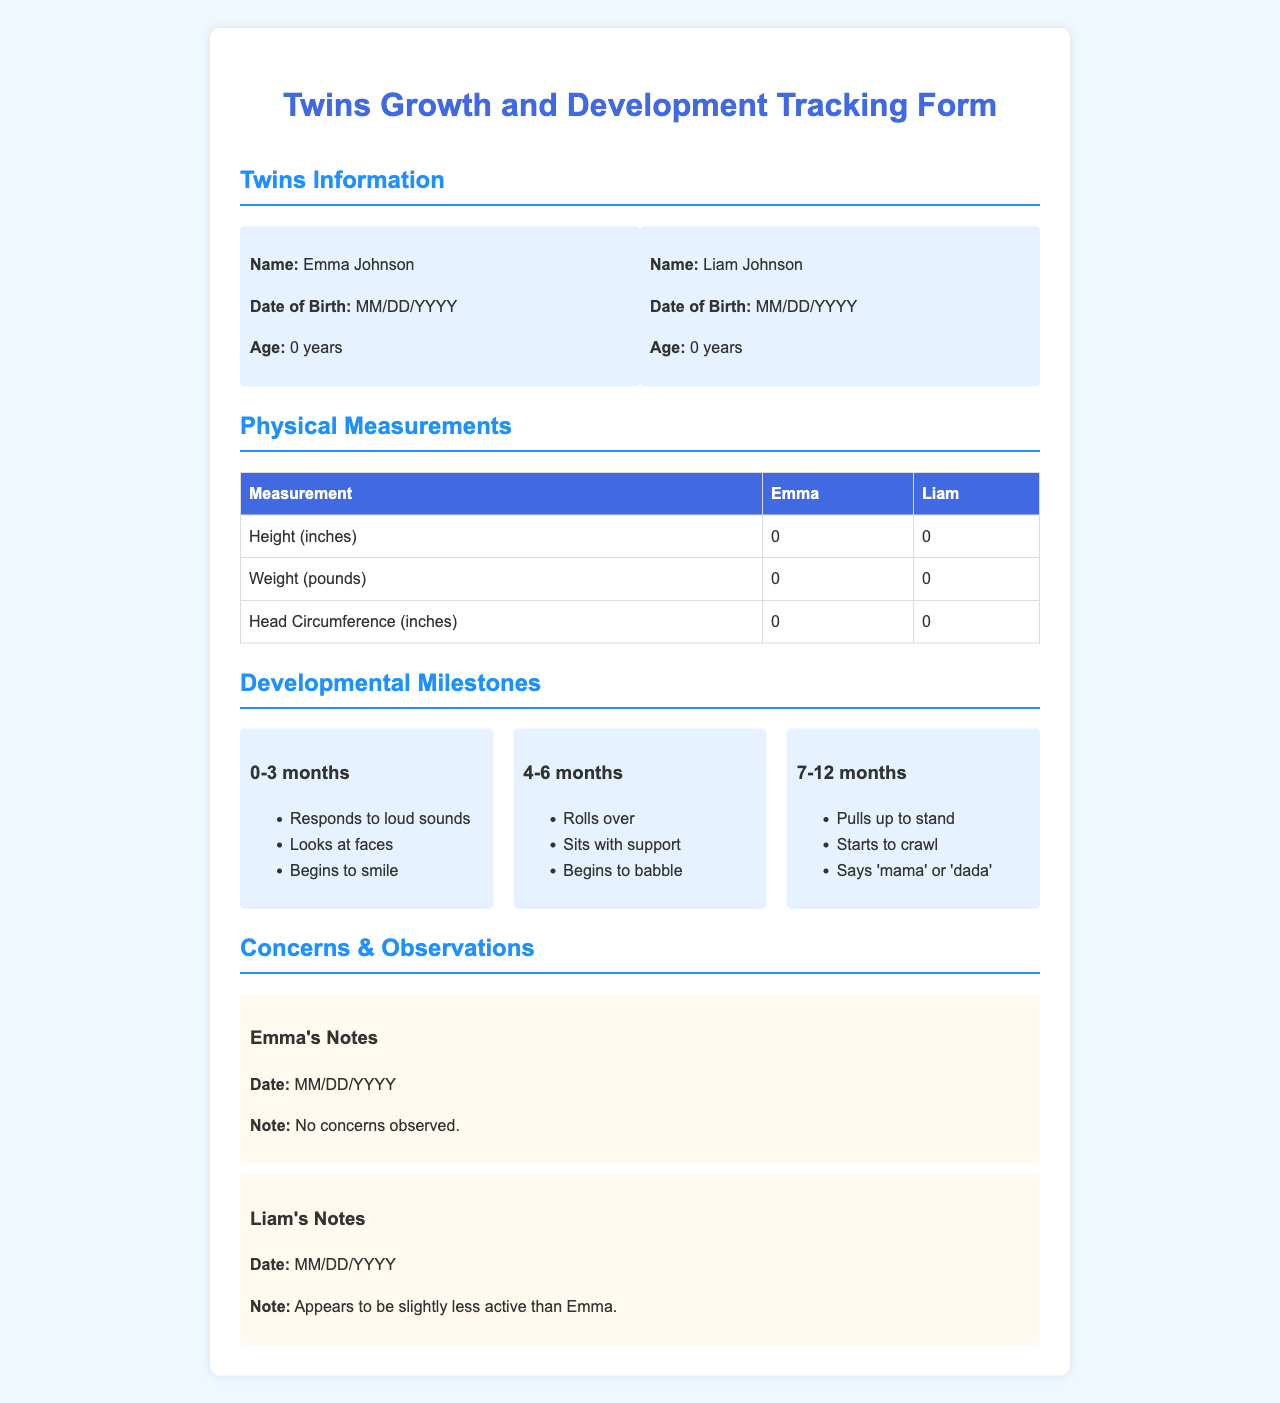What are the names of the twins? The document lists the names of the twins as Emma Johnson and Liam Johnson.
Answer: Emma Johnson, Liam Johnson What is the age of each twin? Both Emma and Liam are indicated to be 0 years old in the document.
Answer: 0 years What is Emma's height measurement? The height measurement for Emma is specified in the document as 0 inches.
Answer: 0 inches What developmental milestone is noted for 4-6 months? One of the milestones for 4-6 months is that the child rolls over.
Answer: Rolls over What note is recorded about Liam? The note about Liam mentions he appears to be slightly less active than Emma.
Answer: Appears to be slightly less active than Emma What is the head circumference measurement for Liam? The head circumference measurement for Liam is stated as 0 inches in the document.
Answer: 0 inches What is the date of birth format used in the document? The document uses the format MM/DD/YYYY for the date of birth.
Answer: MM/DD/YYYY What milestone is associated with 7-12 months? One of the milestones for 7-12 months is that the child starts to crawl.
Answer: Starts to crawl 